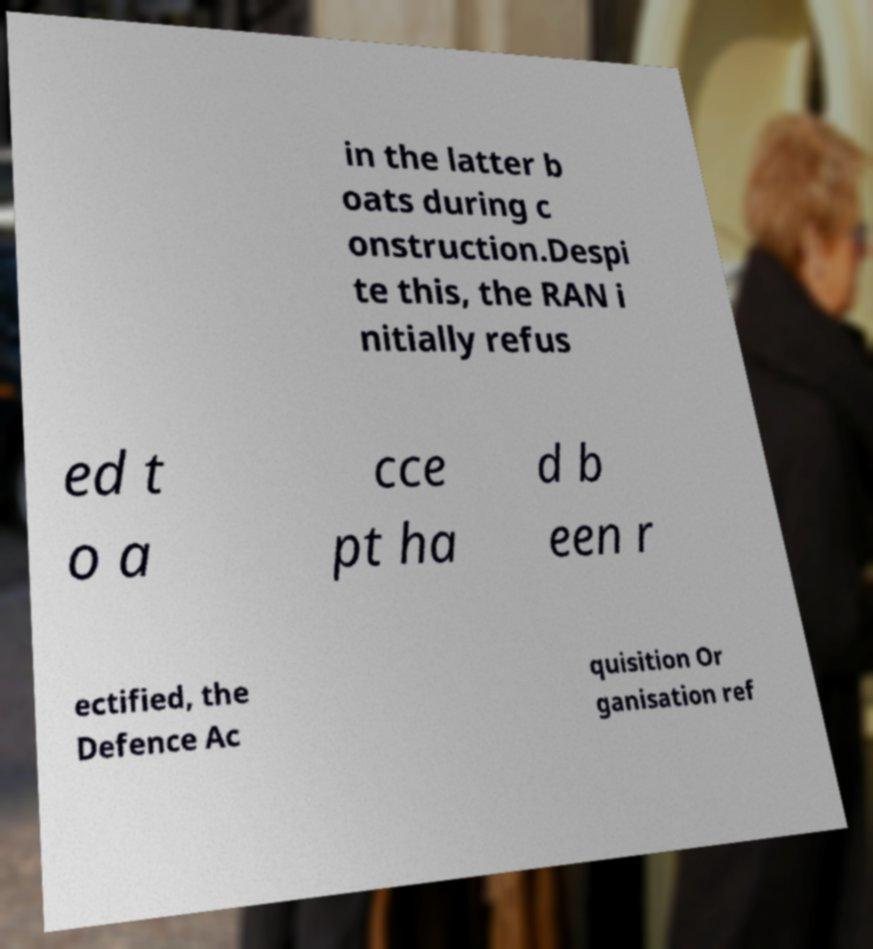Please identify and transcribe the text found in this image. in the latter b oats during c onstruction.Despi te this, the RAN i nitially refus ed t o a cce pt ha d b een r ectified, the Defence Ac quisition Or ganisation ref 